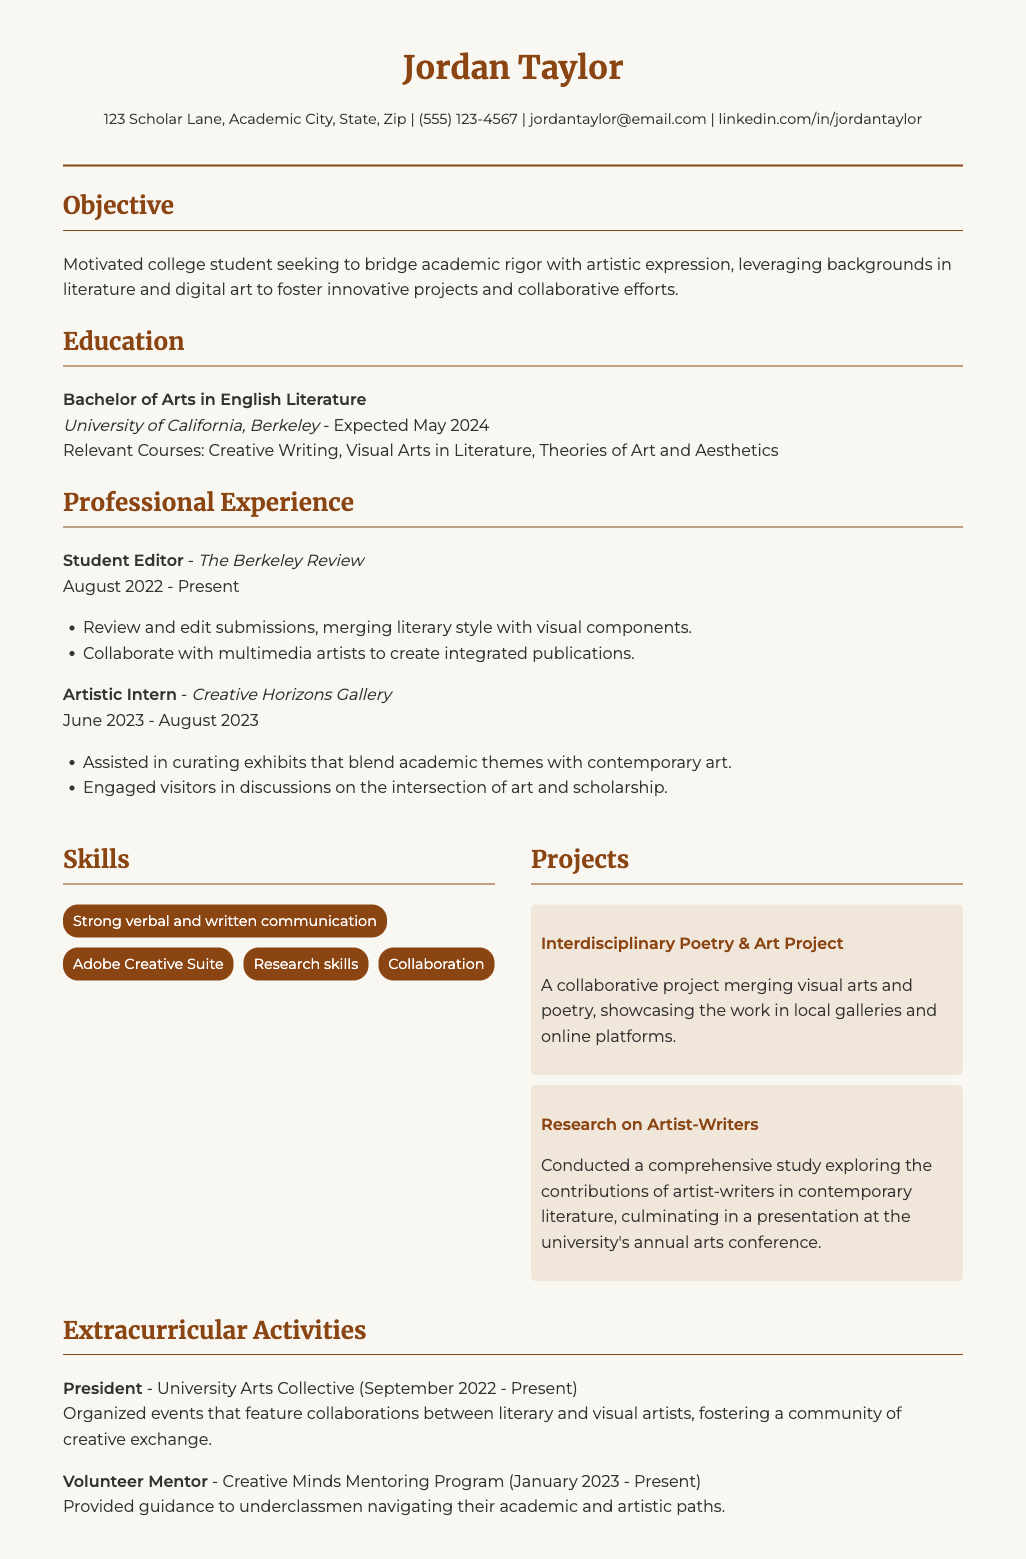What is the degree Jordan Taylor is pursuing? The degree is mentioned in the education section as Bachelor of Arts in English Literature.
Answer: Bachelor of Arts in English Literature When is Jordan Taylor expected to graduate? The expected graduation date is specified in the education section as May 2024.
Answer: May 2024 What role does Jordan hold at The Berkeley Review? The job title at The Berkeley Review is listed as Student Editor in the professional experience section.
Answer: Student Editor Which two skills are highlighted in Jordan's resume? The skills section mentions multiple skills, but two notable ones are Strong verbal and written communication and Adobe Creative Suite.
Answer: Strong verbal and written communication, Adobe Creative Suite What project involved merging visual arts and poetry? The project is named Interdisciplinary Poetry & Art Project, as stated in the projects section.
Answer: Interdisciplinary Poetry & Art Project Which organization does Jordan lead as President? The extracurricular activities section lists University Arts Collective, where Jordan serves as President.
Answer: University Arts Collective How long has Jordan been a volunteer mentor? The start date for the volunteer mentor position is listed as January 2023, and it's currently ongoing, indicating a duration of approximately 10 months as of now.
Answer: January 2023 - Present What type of gallery did Jordan intern at? The position held was Artistic Intern at Creative Horizons Gallery, as stated in the professional experience section.
Answer: Creative Horizons Gallery What is the main theme of the research project? The research project focuses on the contributions of artist-writers in contemporary literature, as indicated in the project description.
Answer: Contributions of artist-writers in contemporary literature 